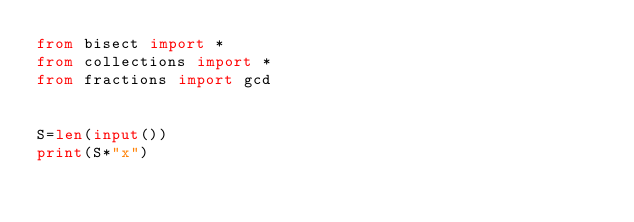Convert code to text. <code><loc_0><loc_0><loc_500><loc_500><_Python_>from bisect import *
from collections import *
from fractions import gcd


S=len(input())
print(S*"x")
</code> 